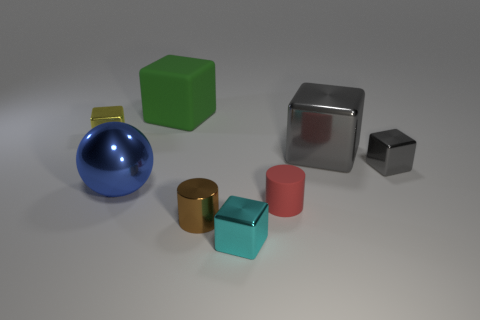Subtract all yellow blocks. How many blocks are left? 4 Subtract all small yellow metal blocks. How many blocks are left? 4 Subtract all purple cubes. Subtract all green cylinders. How many cubes are left? 5 Add 2 small brown metallic things. How many objects exist? 10 Subtract all cylinders. How many objects are left? 6 Add 8 big gray cubes. How many big gray cubes exist? 9 Subtract 0 gray cylinders. How many objects are left? 8 Subtract all red cylinders. Subtract all small yellow blocks. How many objects are left? 6 Add 8 big gray things. How many big gray things are left? 9 